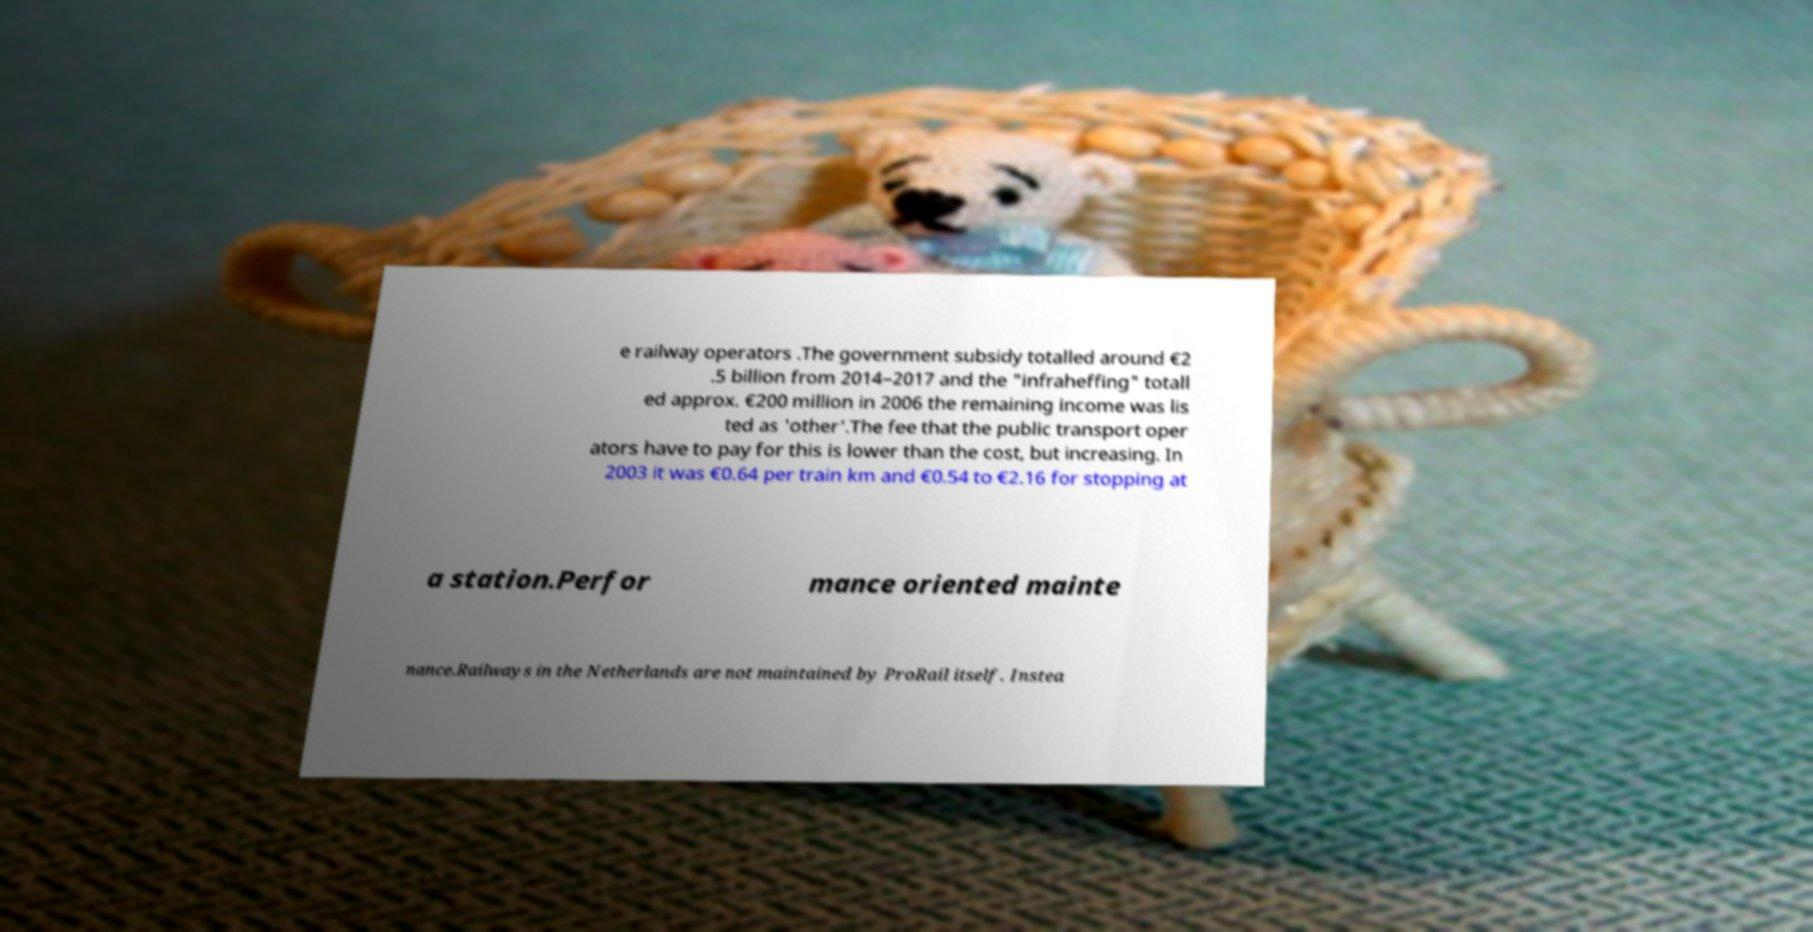I need the written content from this picture converted into text. Can you do that? e railway operators .The government subsidy totalled around €2 .5 billion from 2014–2017 and the "infraheffing" totall ed approx. €200 million in 2006 the remaining income was lis ted as 'other'.The fee that the public transport oper ators have to pay for this is lower than the cost, but increasing. In 2003 it was €0.64 per train km and €0.54 to €2.16 for stopping at a station.Perfor mance oriented mainte nance.Railways in the Netherlands are not maintained by ProRail itself. Instea 